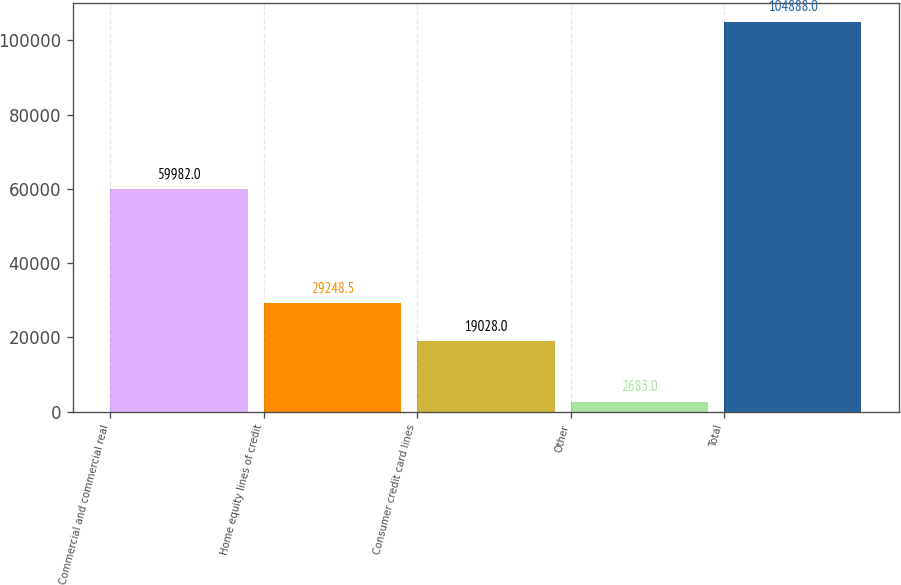Convert chart. <chart><loc_0><loc_0><loc_500><loc_500><bar_chart><fcel>Commercial and commercial real<fcel>Home equity lines of credit<fcel>Consumer credit card lines<fcel>Other<fcel>Total<nl><fcel>59982<fcel>29248.5<fcel>19028<fcel>2683<fcel>104888<nl></chart> 